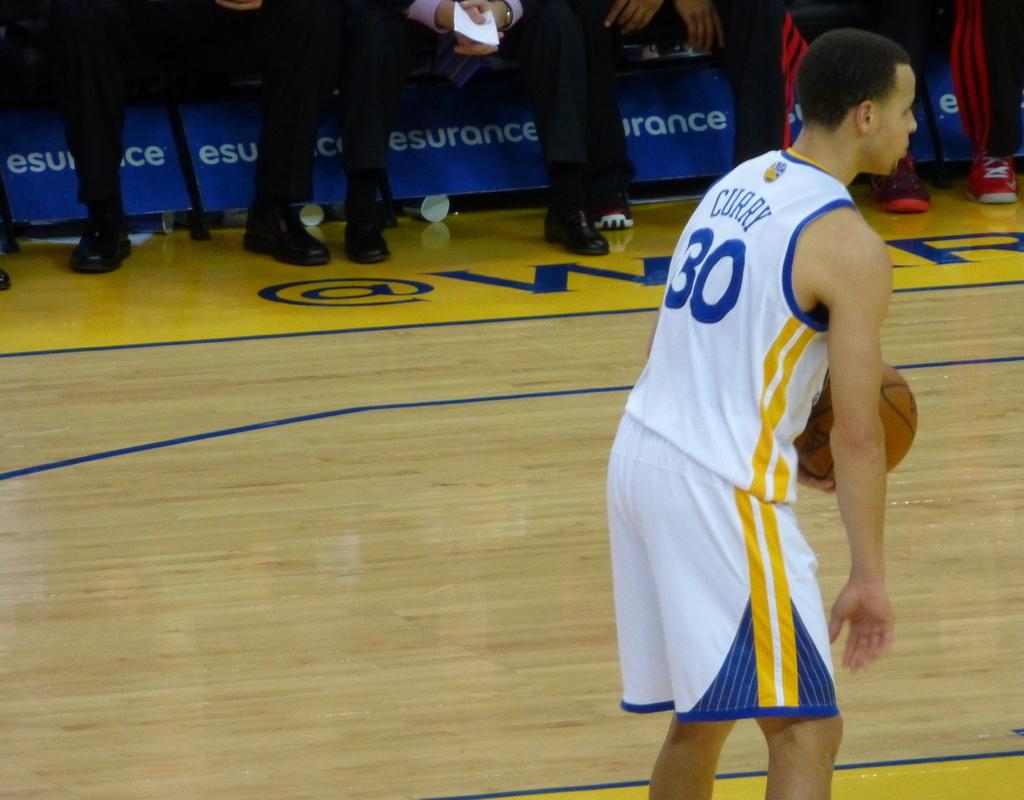Which player is that?
Keep it short and to the point. Curry. What jersey number is curry?
Ensure brevity in your answer.  30. 